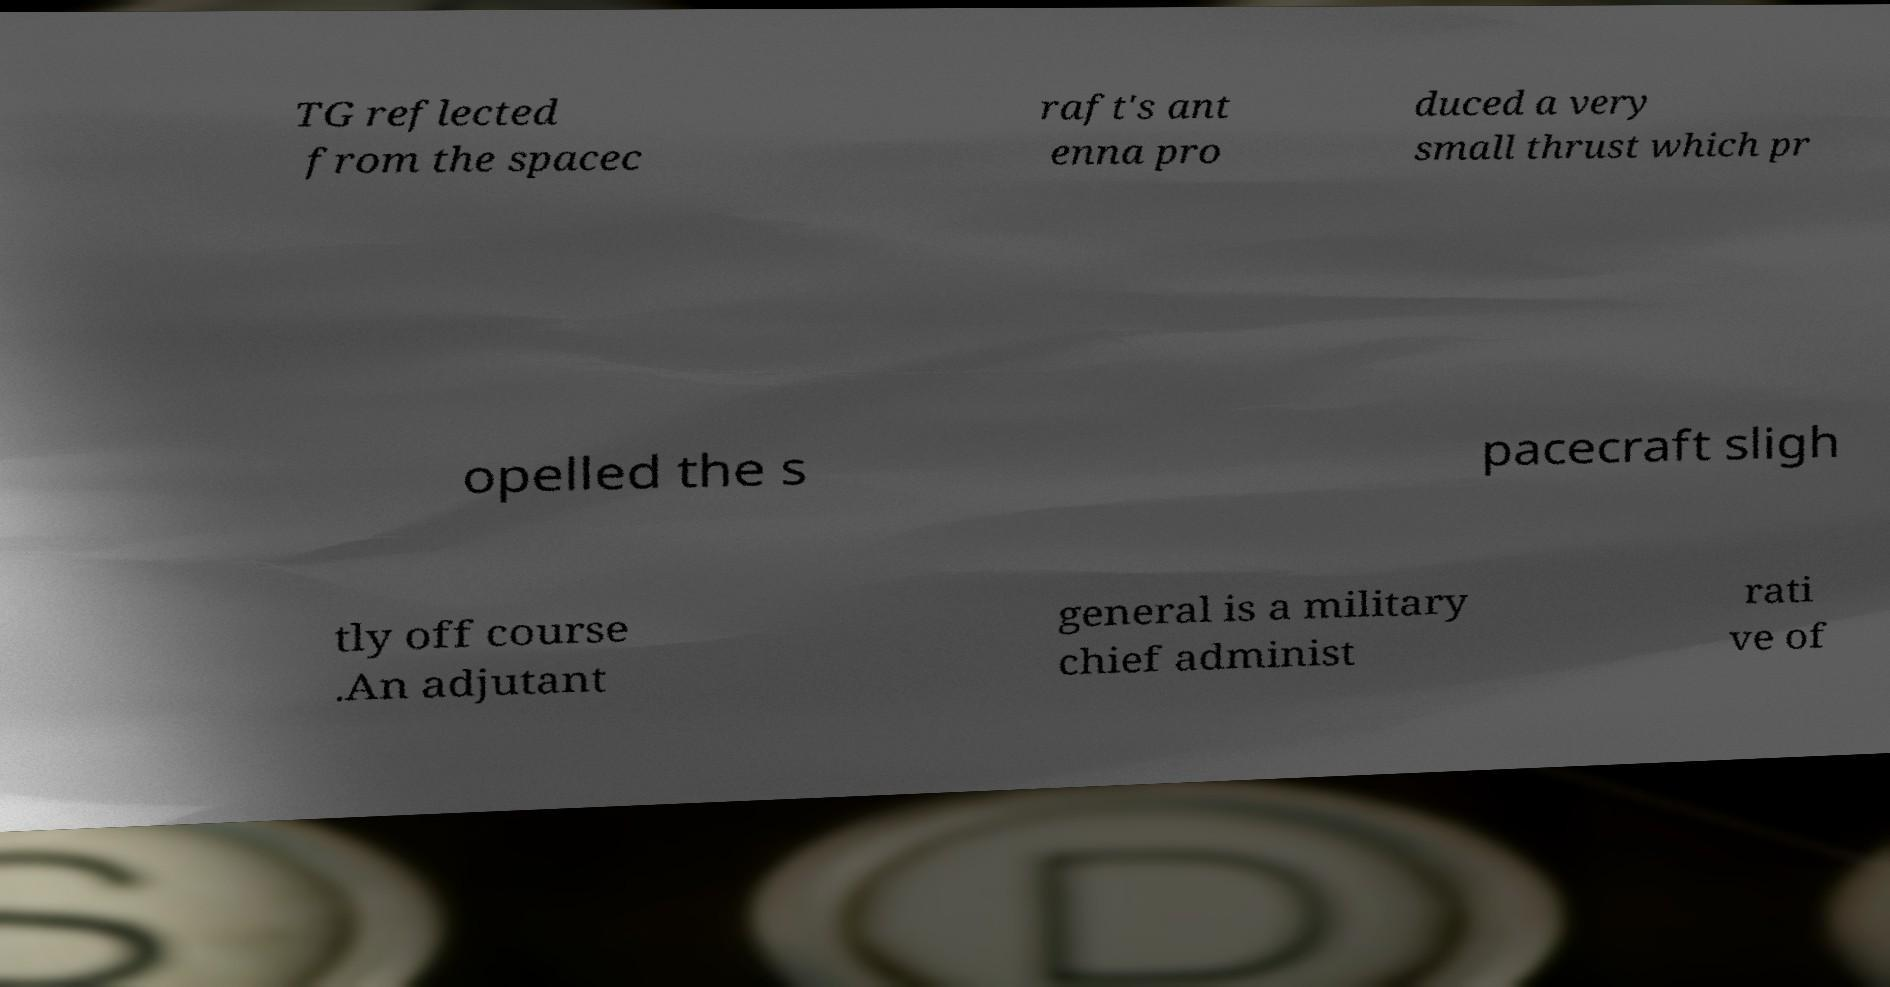What messages or text are displayed in this image? I need them in a readable, typed format. TG reflected from the spacec raft's ant enna pro duced a very small thrust which pr opelled the s pacecraft sligh tly off course .An adjutant general is a military chief administ rati ve of 